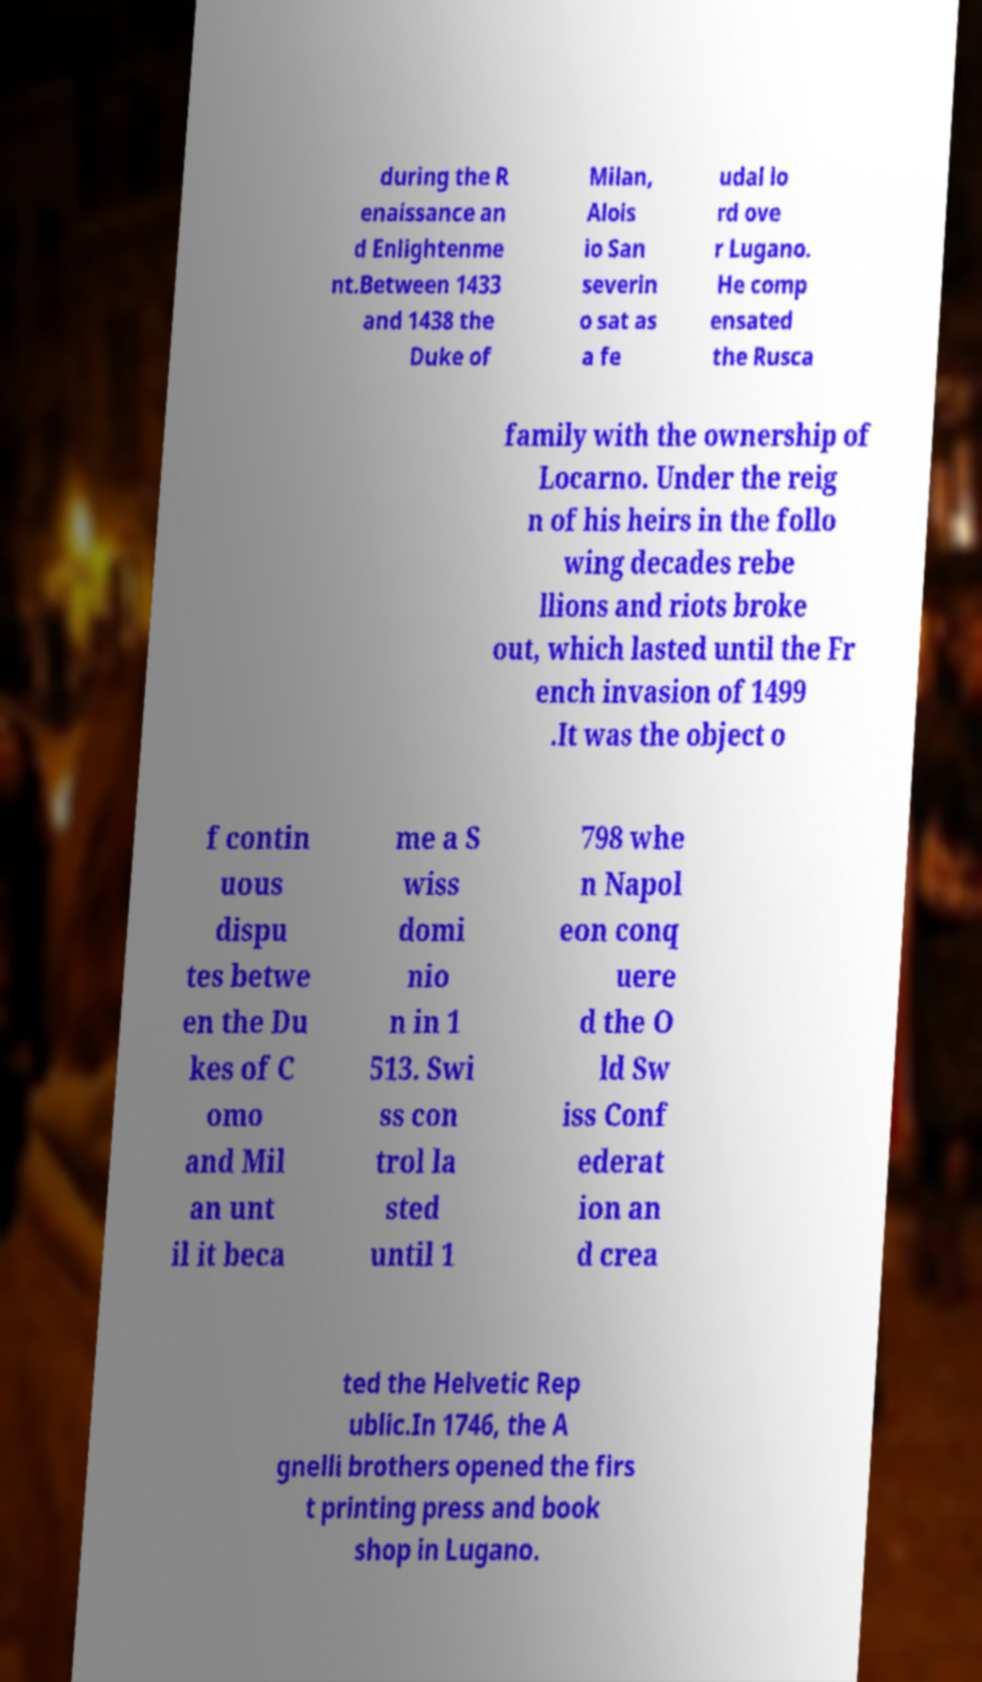Please read and relay the text visible in this image. What does it say? during the R enaissance an d Enlightenme nt.Between 1433 and 1438 the Duke of Milan, Alois io San severin o sat as a fe udal lo rd ove r Lugano. He comp ensated the Rusca family with the ownership of Locarno. Under the reig n of his heirs in the follo wing decades rebe llions and riots broke out, which lasted until the Fr ench invasion of 1499 .It was the object o f contin uous dispu tes betwe en the Du kes of C omo and Mil an unt il it beca me a S wiss domi nio n in 1 513. Swi ss con trol la sted until 1 798 whe n Napol eon conq uere d the O ld Sw iss Conf ederat ion an d crea ted the Helvetic Rep ublic.In 1746, the A gnelli brothers opened the firs t printing press and book shop in Lugano. 